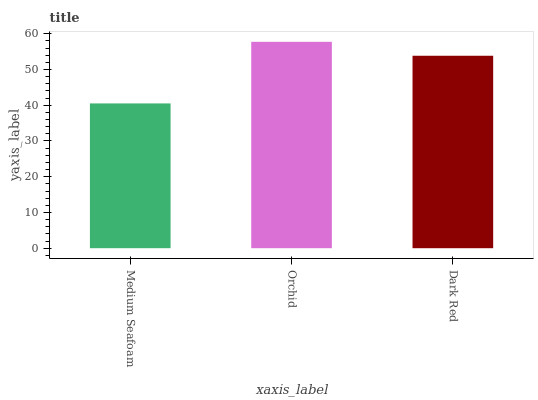Is Medium Seafoam the minimum?
Answer yes or no. Yes. Is Orchid the maximum?
Answer yes or no. Yes. Is Dark Red the minimum?
Answer yes or no. No. Is Dark Red the maximum?
Answer yes or no. No. Is Orchid greater than Dark Red?
Answer yes or no. Yes. Is Dark Red less than Orchid?
Answer yes or no. Yes. Is Dark Red greater than Orchid?
Answer yes or no. No. Is Orchid less than Dark Red?
Answer yes or no. No. Is Dark Red the high median?
Answer yes or no. Yes. Is Dark Red the low median?
Answer yes or no. Yes. Is Orchid the high median?
Answer yes or no. No. Is Orchid the low median?
Answer yes or no. No. 